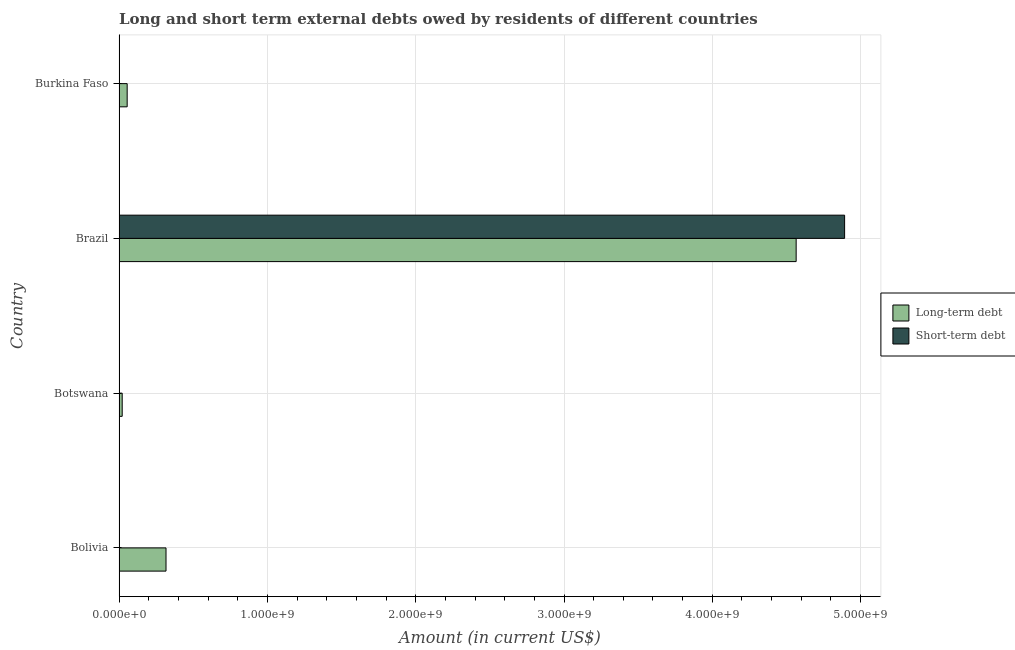How many different coloured bars are there?
Your answer should be very brief. 2. Are the number of bars on each tick of the Y-axis equal?
Make the answer very short. No. How many bars are there on the 1st tick from the top?
Give a very brief answer. 1. In how many cases, is the number of bars for a given country not equal to the number of legend labels?
Keep it short and to the point. 3. Across all countries, what is the maximum short-term debts owed by residents?
Ensure brevity in your answer.  4.89e+09. Across all countries, what is the minimum short-term debts owed by residents?
Make the answer very short. 0. What is the total long-term debts owed by residents in the graph?
Make the answer very short. 4.96e+09. What is the difference between the long-term debts owed by residents in Botswana and that in Burkina Faso?
Your answer should be very brief. -3.35e+07. What is the difference between the long-term debts owed by residents in Botswana and the short-term debts owed by residents in Bolivia?
Offer a terse response. 2.13e+07. What is the average short-term debts owed by residents per country?
Offer a terse response. 1.22e+09. What is the difference between the long-term debts owed by residents and short-term debts owed by residents in Brazil?
Keep it short and to the point. -3.27e+08. What is the ratio of the long-term debts owed by residents in Botswana to that in Brazil?
Keep it short and to the point. 0.01. What is the difference between the highest and the second highest long-term debts owed by residents?
Offer a very short reply. 4.25e+09. What is the difference between the highest and the lowest long-term debts owed by residents?
Make the answer very short. 4.54e+09. Is the sum of the long-term debts owed by residents in Bolivia and Brazil greater than the maximum short-term debts owed by residents across all countries?
Provide a succinct answer. No. Are all the bars in the graph horizontal?
Make the answer very short. Yes. How many countries are there in the graph?
Ensure brevity in your answer.  4. What is the difference between two consecutive major ticks on the X-axis?
Offer a very short reply. 1.00e+09. Are the values on the major ticks of X-axis written in scientific E-notation?
Make the answer very short. Yes. Does the graph contain any zero values?
Keep it short and to the point. Yes. How many legend labels are there?
Provide a short and direct response. 2. What is the title of the graph?
Provide a succinct answer. Long and short term external debts owed by residents of different countries. What is the label or title of the X-axis?
Your response must be concise. Amount (in current US$). What is the label or title of the Y-axis?
Offer a terse response. Country. What is the Amount (in current US$) in Long-term debt in Bolivia?
Offer a terse response. 3.17e+08. What is the Amount (in current US$) in Long-term debt in Botswana?
Ensure brevity in your answer.  2.13e+07. What is the Amount (in current US$) in Short-term debt in Botswana?
Your answer should be compact. 0. What is the Amount (in current US$) of Long-term debt in Brazil?
Keep it short and to the point. 4.57e+09. What is the Amount (in current US$) of Short-term debt in Brazil?
Keep it short and to the point. 4.89e+09. What is the Amount (in current US$) in Long-term debt in Burkina Faso?
Provide a succinct answer. 5.48e+07. What is the Amount (in current US$) of Short-term debt in Burkina Faso?
Offer a terse response. 0. Across all countries, what is the maximum Amount (in current US$) of Long-term debt?
Give a very brief answer. 4.57e+09. Across all countries, what is the maximum Amount (in current US$) of Short-term debt?
Provide a short and direct response. 4.89e+09. Across all countries, what is the minimum Amount (in current US$) in Long-term debt?
Provide a short and direct response. 2.13e+07. What is the total Amount (in current US$) of Long-term debt in the graph?
Offer a terse response. 4.96e+09. What is the total Amount (in current US$) of Short-term debt in the graph?
Provide a short and direct response. 4.89e+09. What is the difference between the Amount (in current US$) of Long-term debt in Bolivia and that in Botswana?
Offer a very short reply. 2.95e+08. What is the difference between the Amount (in current US$) of Long-term debt in Bolivia and that in Brazil?
Make the answer very short. -4.25e+09. What is the difference between the Amount (in current US$) in Long-term debt in Bolivia and that in Burkina Faso?
Provide a succinct answer. 2.62e+08. What is the difference between the Amount (in current US$) in Long-term debt in Botswana and that in Brazil?
Your response must be concise. -4.54e+09. What is the difference between the Amount (in current US$) in Long-term debt in Botswana and that in Burkina Faso?
Offer a very short reply. -3.35e+07. What is the difference between the Amount (in current US$) in Long-term debt in Brazil and that in Burkina Faso?
Keep it short and to the point. 4.51e+09. What is the difference between the Amount (in current US$) in Long-term debt in Bolivia and the Amount (in current US$) in Short-term debt in Brazil?
Keep it short and to the point. -4.58e+09. What is the difference between the Amount (in current US$) in Long-term debt in Botswana and the Amount (in current US$) in Short-term debt in Brazil?
Offer a very short reply. -4.87e+09. What is the average Amount (in current US$) of Long-term debt per country?
Your answer should be very brief. 1.24e+09. What is the average Amount (in current US$) in Short-term debt per country?
Your answer should be compact. 1.22e+09. What is the difference between the Amount (in current US$) in Long-term debt and Amount (in current US$) in Short-term debt in Brazil?
Make the answer very short. -3.27e+08. What is the ratio of the Amount (in current US$) in Long-term debt in Bolivia to that in Botswana?
Give a very brief answer. 14.88. What is the ratio of the Amount (in current US$) of Long-term debt in Bolivia to that in Brazil?
Provide a short and direct response. 0.07. What is the ratio of the Amount (in current US$) of Long-term debt in Bolivia to that in Burkina Faso?
Provide a short and direct response. 5.78. What is the ratio of the Amount (in current US$) in Long-term debt in Botswana to that in Brazil?
Give a very brief answer. 0. What is the ratio of the Amount (in current US$) in Long-term debt in Botswana to that in Burkina Faso?
Give a very brief answer. 0.39. What is the ratio of the Amount (in current US$) of Long-term debt in Brazil to that in Burkina Faso?
Your response must be concise. 83.35. What is the difference between the highest and the second highest Amount (in current US$) in Long-term debt?
Give a very brief answer. 4.25e+09. What is the difference between the highest and the lowest Amount (in current US$) in Long-term debt?
Provide a short and direct response. 4.54e+09. What is the difference between the highest and the lowest Amount (in current US$) in Short-term debt?
Your answer should be compact. 4.89e+09. 